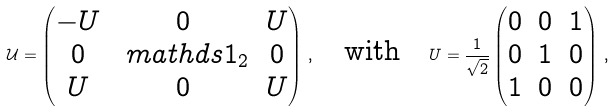<formula> <loc_0><loc_0><loc_500><loc_500>\mathcal { U } = \begin{pmatrix} - U & 0 & U \\ 0 & \ m a t h d s { 1 } _ { 2 } & 0 \\ U & 0 & U \end{pmatrix} \, , \quad \text {with} \quad U = \frac { 1 } { \sqrt { 2 } } \begin{pmatrix} 0 & 0 & 1 \\ 0 & 1 & 0 \\ 1 & 0 & 0 \end{pmatrix} \, ,</formula> 